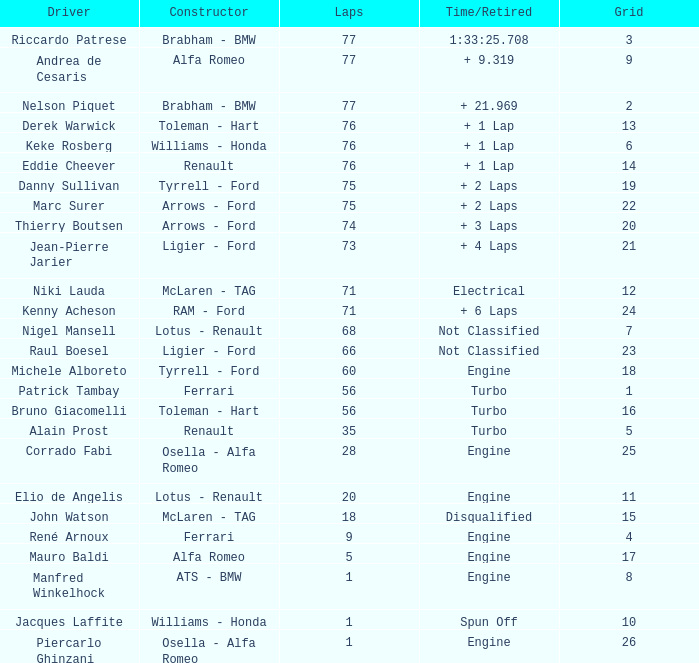Who drive the car that went under 60 laps and spun off? Jacques Laffite. 